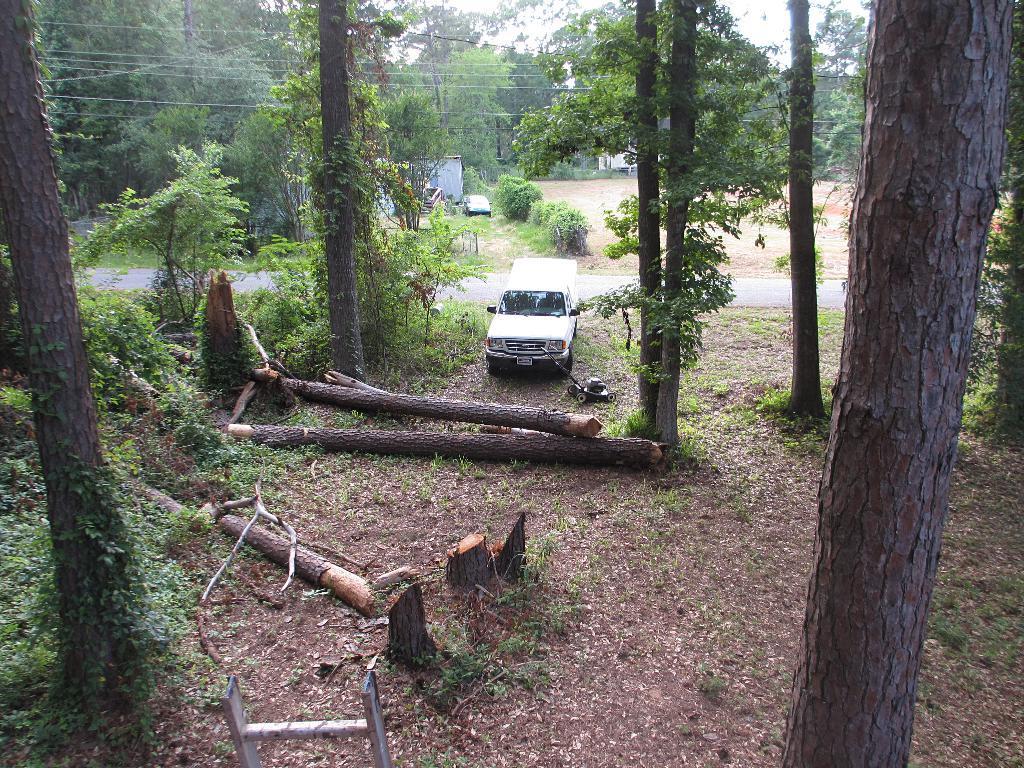In one or two sentences, can you explain what this image depicts? At the bottom we can see cut down trees,metal object and leaves on the ground. There are trees and a vehicle on the ground. In the background we can see road and to the other side of the road we can see vehicle,houses,trees,electric wires,poles and sky. 